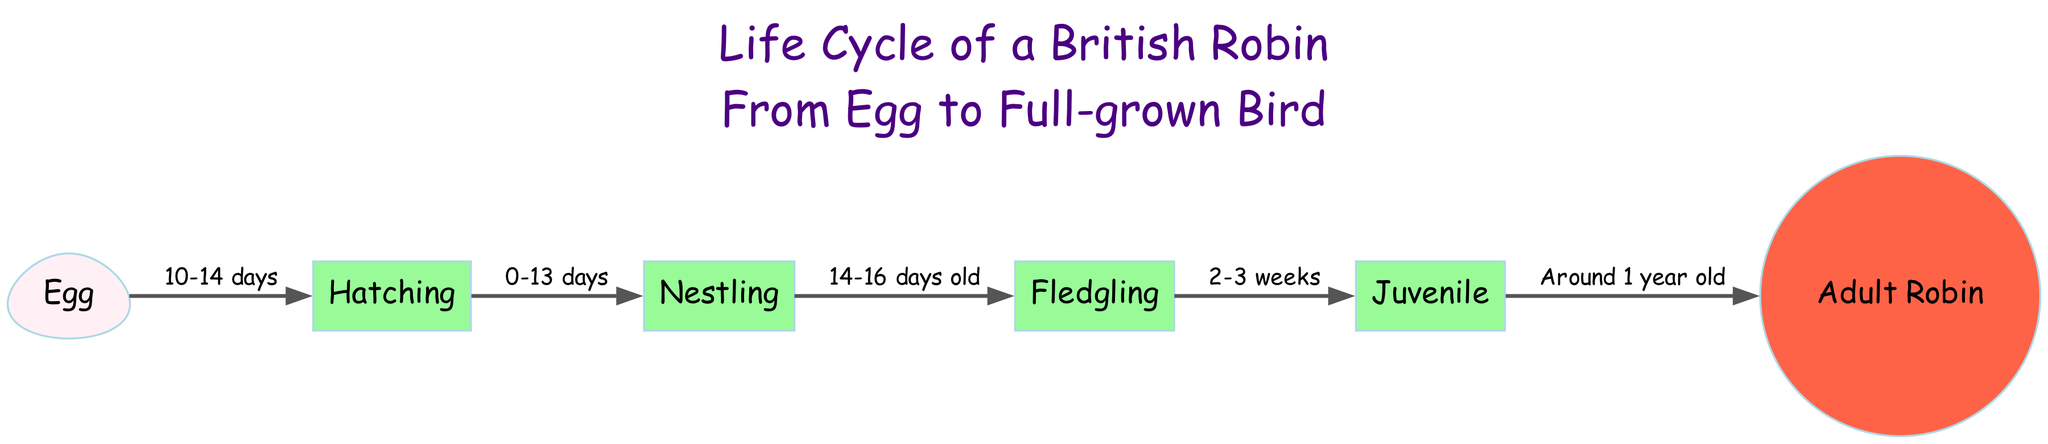What is the starting stage of the life cycle? The diagram shows the first node labeled "Egg," indicating that the life cycle begins with an egg.
Answer: Egg How long does it take for the egg to hatch? The edge from "Egg" to "Hatching" states "10-14 days," indicating the hatching period after the egg is laid.
Answer: 10-14 days What is the next stage after hatching? After the "Hatching" stage, the next node visually connected is labeled "Nestling," indicating the sequential stage in the life cycle.
Answer: Nestling What is the duration for the nestling stage before becoming a fledgling? The edge from "Nestling" to "Fledgling" denotes "14-16 days old," indicating the time spent in the nestling stage before fledging.
Answer: 14-16 days old At what stage does the robin become juvenile? The transition from "Fledgling" to "Juvenile" occurs after "2-3 weeks," indicating the time it takes to reach the juvenile stage.
Answer: 2-3 weeks How long does it take for a juvenile robin to become an adult? The final edge from "Juvenile" to "Adult Robin" is labeled "Around 1 year old," indicating the time it takes to reach adulthood.
Answer: Around 1 year old How many total stages are depicted in the life cycle? The diagram includes six distinct nodes representing various stages in the life cycle: Egg, Hatching, Nestling, Fledgling, Juvenile, and Adult Robin.
Answer: 6 What shape represents the adult stage of the robin? The node labeled "Adult Robin" is represented by a "circle" shape, which differentiates it visually from other stages.
Answer: Circle 